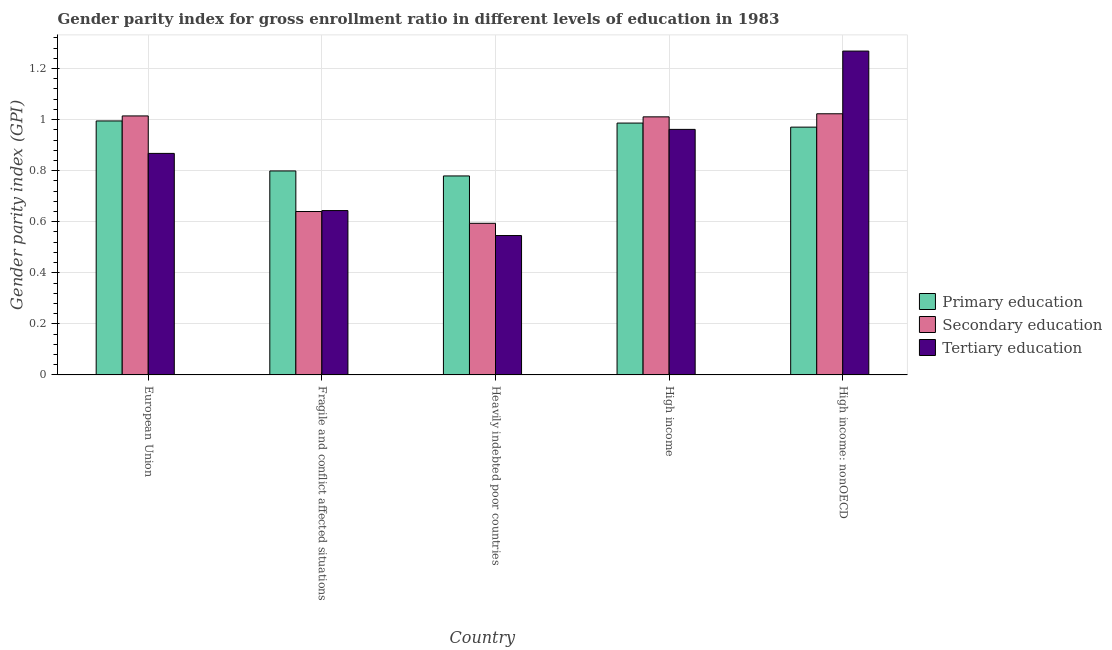Are the number of bars per tick equal to the number of legend labels?
Your answer should be compact. Yes. What is the label of the 5th group of bars from the left?
Ensure brevity in your answer.  High income: nonOECD. In how many cases, is the number of bars for a given country not equal to the number of legend labels?
Your answer should be compact. 0. What is the gender parity index in secondary education in High income?
Offer a terse response. 1.01. Across all countries, what is the maximum gender parity index in primary education?
Your answer should be very brief. 0.99. Across all countries, what is the minimum gender parity index in secondary education?
Give a very brief answer. 0.59. In which country was the gender parity index in secondary education maximum?
Make the answer very short. High income: nonOECD. In which country was the gender parity index in primary education minimum?
Offer a terse response. Heavily indebted poor countries. What is the total gender parity index in primary education in the graph?
Offer a terse response. 4.53. What is the difference between the gender parity index in secondary education in Fragile and conflict affected situations and that in Heavily indebted poor countries?
Your response must be concise. 0.05. What is the difference between the gender parity index in secondary education in Heavily indebted poor countries and the gender parity index in tertiary education in Fragile and conflict affected situations?
Make the answer very short. -0.05. What is the average gender parity index in primary education per country?
Offer a terse response. 0.91. What is the difference between the gender parity index in primary education and gender parity index in secondary education in Fragile and conflict affected situations?
Your answer should be very brief. 0.16. What is the ratio of the gender parity index in primary education in Heavily indebted poor countries to that in High income: nonOECD?
Give a very brief answer. 0.8. Is the gender parity index in primary education in Heavily indebted poor countries less than that in High income?
Offer a terse response. Yes. What is the difference between the highest and the second highest gender parity index in secondary education?
Provide a succinct answer. 0.01. What is the difference between the highest and the lowest gender parity index in secondary education?
Provide a succinct answer. 0.43. In how many countries, is the gender parity index in tertiary education greater than the average gender parity index in tertiary education taken over all countries?
Make the answer very short. 3. What does the 2nd bar from the left in Fragile and conflict affected situations represents?
Provide a short and direct response. Secondary education. What does the 3rd bar from the right in European Union represents?
Your answer should be very brief. Primary education. Is it the case that in every country, the sum of the gender parity index in primary education and gender parity index in secondary education is greater than the gender parity index in tertiary education?
Offer a very short reply. Yes. How many bars are there?
Keep it short and to the point. 15. How many countries are there in the graph?
Provide a succinct answer. 5. Are the values on the major ticks of Y-axis written in scientific E-notation?
Provide a succinct answer. No. Where does the legend appear in the graph?
Your answer should be compact. Center right. How are the legend labels stacked?
Give a very brief answer. Vertical. What is the title of the graph?
Make the answer very short. Gender parity index for gross enrollment ratio in different levels of education in 1983. What is the label or title of the Y-axis?
Your answer should be very brief. Gender parity index (GPI). What is the Gender parity index (GPI) in Primary education in European Union?
Your response must be concise. 0.99. What is the Gender parity index (GPI) of Secondary education in European Union?
Your answer should be compact. 1.01. What is the Gender parity index (GPI) of Tertiary education in European Union?
Make the answer very short. 0.87. What is the Gender parity index (GPI) in Primary education in Fragile and conflict affected situations?
Your answer should be compact. 0.8. What is the Gender parity index (GPI) of Secondary education in Fragile and conflict affected situations?
Your answer should be compact. 0.64. What is the Gender parity index (GPI) of Tertiary education in Fragile and conflict affected situations?
Give a very brief answer. 0.64. What is the Gender parity index (GPI) of Primary education in Heavily indebted poor countries?
Keep it short and to the point. 0.78. What is the Gender parity index (GPI) of Secondary education in Heavily indebted poor countries?
Offer a terse response. 0.59. What is the Gender parity index (GPI) of Tertiary education in Heavily indebted poor countries?
Keep it short and to the point. 0.55. What is the Gender parity index (GPI) of Primary education in High income?
Give a very brief answer. 0.99. What is the Gender parity index (GPI) in Secondary education in High income?
Your response must be concise. 1.01. What is the Gender parity index (GPI) of Tertiary education in High income?
Make the answer very short. 0.96. What is the Gender parity index (GPI) of Primary education in High income: nonOECD?
Give a very brief answer. 0.97. What is the Gender parity index (GPI) of Secondary education in High income: nonOECD?
Provide a short and direct response. 1.02. What is the Gender parity index (GPI) of Tertiary education in High income: nonOECD?
Provide a succinct answer. 1.27. Across all countries, what is the maximum Gender parity index (GPI) of Primary education?
Give a very brief answer. 0.99. Across all countries, what is the maximum Gender parity index (GPI) in Secondary education?
Keep it short and to the point. 1.02. Across all countries, what is the maximum Gender parity index (GPI) of Tertiary education?
Keep it short and to the point. 1.27. Across all countries, what is the minimum Gender parity index (GPI) in Primary education?
Ensure brevity in your answer.  0.78. Across all countries, what is the minimum Gender parity index (GPI) in Secondary education?
Offer a terse response. 0.59. Across all countries, what is the minimum Gender parity index (GPI) of Tertiary education?
Make the answer very short. 0.55. What is the total Gender parity index (GPI) of Primary education in the graph?
Your answer should be very brief. 4.53. What is the total Gender parity index (GPI) of Secondary education in the graph?
Ensure brevity in your answer.  4.28. What is the total Gender parity index (GPI) in Tertiary education in the graph?
Provide a succinct answer. 4.29. What is the difference between the Gender parity index (GPI) in Primary education in European Union and that in Fragile and conflict affected situations?
Offer a very short reply. 0.2. What is the difference between the Gender parity index (GPI) of Secondary education in European Union and that in Fragile and conflict affected situations?
Your answer should be very brief. 0.37. What is the difference between the Gender parity index (GPI) of Tertiary education in European Union and that in Fragile and conflict affected situations?
Provide a short and direct response. 0.22. What is the difference between the Gender parity index (GPI) in Primary education in European Union and that in Heavily indebted poor countries?
Your response must be concise. 0.22. What is the difference between the Gender parity index (GPI) of Secondary education in European Union and that in Heavily indebted poor countries?
Your response must be concise. 0.42. What is the difference between the Gender parity index (GPI) of Tertiary education in European Union and that in Heavily indebted poor countries?
Your answer should be very brief. 0.32. What is the difference between the Gender parity index (GPI) of Primary education in European Union and that in High income?
Your response must be concise. 0.01. What is the difference between the Gender parity index (GPI) in Secondary education in European Union and that in High income?
Offer a very short reply. 0. What is the difference between the Gender parity index (GPI) in Tertiary education in European Union and that in High income?
Your answer should be very brief. -0.09. What is the difference between the Gender parity index (GPI) in Primary education in European Union and that in High income: nonOECD?
Make the answer very short. 0.02. What is the difference between the Gender parity index (GPI) of Secondary education in European Union and that in High income: nonOECD?
Your answer should be very brief. -0.01. What is the difference between the Gender parity index (GPI) of Tertiary education in European Union and that in High income: nonOECD?
Your answer should be compact. -0.4. What is the difference between the Gender parity index (GPI) in Primary education in Fragile and conflict affected situations and that in Heavily indebted poor countries?
Keep it short and to the point. 0.02. What is the difference between the Gender parity index (GPI) of Secondary education in Fragile and conflict affected situations and that in Heavily indebted poor countries?
Ensure brevity in your answer.  0.05. What is the difference between the Gender parity index (GPI) of Tertiary education in Fragile and conflict affected situations and that in Heavily indebted poor countries?
Give a very brief answer. 0.1. What is the difference between the Gender parity index (GPI) of Primary education in Fragile and conflict affected situations and that in High income?
Your answer should be very brief. -0.19. What is the difference between the Gender parity index (GPI) of Secondary education in Fragile and conflict affected situations and that in High income?
Give a very brief answer. -0.37. What is the difference between the Gender parity index (GPI) in Tertiary education in Fragile and conflict affected situations and that in High income?
Provide a short and direct response. -0.32. What is the difference between the Gender parity index (GPI) in Primary education in Fragile and conflict affected situations and that in High income: nonOECD?
Provide a short and direct response. -0.17. What is the difference between the Gender parity index (GPI) of Secondary education in Fragile and conflict affected situations and that in High income: nonOECD?
Provide a succinct answer. -0.38. What is the difference between the Gender parity index (GPI) of Tertiary education in Fragile and conflict affected situations and that in High income: nonOECD?
Keep it short and to the point. -0.62. What is the difference between the Gender parity index (GPI) of Primary education in Heavily indebted poor countries and that in High income?
Offer a terse response. -0.21. What is the difference between the Gender parity index (GPI) of Secondary education in Heavily indebted poor countries and that in High income?
Your response must be concise. -0.42. What is the difference between the Gender parity index (GPI) in Tertiary education in Heavily indebted poor countries and that in High income?
Provide a succinct answer. -0.42. What is the difference between the Gender parity index (GPI) in Primary education in Heavily indebted poor countries and that in High income: nonOECD?
Your answer should be compact. -0.19. What is the difference between the Gender parity index (GPI) in Secondary education in Heavily indebted poor countries and that in High income: nonOECD?
Give a very brief answer. -0.43. What is the difference between the Gender parity index (GPI) in Tertiary education in Heavily indebted poor countries and that in High income: nonOECD?
Make the answer very short. -0.72. What is the difference between the Gender parity index (GPI) in Primary education in High income and that in High income: nonOECD?
Offer a terse response. 0.02. What is the difference between the Gender parity index (GPI) of Secondary education in High income and that in High income: nonOECD?
Provide a short and direct response. -0.01. What is the difference between the Gender parity index (GPI) of Tertiary education in High income and that in High income: nonOECD?
Ensure brevity in your answer.  -0.31. What is the difference between the Gender parity index (GPI) in Primary education in European Union and the Gender parity index (GPI) in Secondary education in Fragile and conflict affected situations?
Your answer should be compact. 0.35. What is the difference between the Gender parity index (GPI) in Primary education in European Union and the Gender parity index (GPI) in Tertiary education in Fragile and conflict affected situations?
Offer a terse response. 0.35. What is the difference between the Gender parity index (GPI) of Secondary education in European Union and the Gender parity index (GPI) of Tertiary education in Fragile and conflict affected situations?
Ensure brevity in your answer.  0.37. What is the difference between the Gender parity index (GPI) of Primary education in European Union and the Gender parity index (GPI) of Secondary education in Heavily indebted poor countries?
Keep it short and to the point. 0.4. What is the difference between the Gender parity index (GPI) in Primary education in European Union and the Gender parity index (GPI) in Tertiary education in Heavily indebted poor countries?
Your response must be concise. 0.45. What is the difference between the Gender parity index (GPI) of Secondary education in European Union and the Gender parity index (GPI) of Tertiary education in Heavily indebted poor countries?
Offer a very short reply. 0.47. What is the difference between the Gender parity index (GPI) in Primary education in European Union and the Gender parity index (GPI) in Secondary education in High income?
Offer a very short reply. -0.02. What is the difference between the Gender parity index (GPI) of Primary education in European Union and the Gender parity index (GPI) of Tertiary education in High income?
Offer a terse response. 0.03. What is the difference between the Gender parity index (GPI) of Secondary education in European Union and the Gender parity index (GPI) of Tertiary education in High income?
Provide a short and direct response. 0.05. What is the difference between the Gender parity index (GPI) in Primary education in European Union and the Gender parity index (GPI) in Secondary education in High income: nonOECD?
Provide a short and direct response. -0.03. What is the difference between the Gender parity index (GPI) of Primary education in European Union and the Gender parity index (GPI) of Tertiary education in High income: nonOECD?
Keep it short and to the point. -0.27. What is the difference between the Gender parity index (GPI) of Secondary education in European Union and the Gender parity index (GPI) of Tertiary education in High income: nonOECD?
Your answer should be compact. -0.25. What is the difference between the Gender parity index (GPI) in Primary education in Fragile and conflict affected situations and the Gender parity index (GPI) in Secondary education in Heavily indebted poor countries?
Give a very brief answer. 0.21. What is the difference between the Gender parity index (GPI) in Primary education in Fragile and conflict affected situations and the Gender parity index (GPI) in Tertiary education in Heavily indebted poor countries?
Offer a terse response. 0.25. What is the difference between the Gender parity index (GPI) of Secondary education in Fragile and conflict affected situations and the Gender parity index (GPI) of Tertiary education in Heavily indebted poor countries?
Offer a terse response. 0.09. What is the difference between the Gender parity index (GPI) in Primary education in Fragile and conflict affected situations and the Gender parity index (GPI) in Secondary education in High income?
Your answer should be compact. -0.21. What is the difference between the Gender parity index (GPI) in Primary education in Fragile and conflict affected situations and the Gender parity index (GPI) in Tertiary education in High income?
Make the answer very short. -0.16. What is the difference between the Gender parity index (GPI) of Secondary education in Fragile and conflict affected situations and the Gender parity index (GPI) of Tertiary education in High income?
Keep it short and to the point. -0.32. What is the difference between the Gender parity index (GPI) in Primary education in Fragile and conflict affected situations and the Gender parity index (GPI) in Secondary education in High income: nonOECD?
Your answer should be very brief. -0.22. What is the difference between the Gender parity index (GPI) in Primary education in Fragile and conflict affected situations and the Gender parity index (GPI) in Tertiary education in High income: nonOECD?
Make the answer very short. -0.47. What is the difference between the Gender parity index (GPI) in Secondary education in Fragile and conflict affected situations and the Gender parity index (GPI) in Tertiary education in High income: nonOECD?
Your response must be concise. -0.63. What is the difference between the Gender parity index (GPI) in Primary education in Heavily indebted poor countries and the Gender parity index (GPI) in Secondary education in High income?
Provide a succinct answer. -0.23. What is the difference between the Gender parity index (GPI) of Primary education in Heavily indebted poor countries and the Gender parity index (GPI) of Tertiary education in High income?
Your answer should be very brief. -0.18. What is the difference between the Gender parity index (GPI) in Secondary education in Heavily indebted poor countries and the Gender parity index (GPI) in Tertiary education in High income?
Keep it short and to the point. -0.37. What is the difference between the Gender parity index (GPI) in Primary education in Heavily indebted poor countries and the Gender parity index (GPI) in Secondary education in High income: nonOECD?
Offer a terse response. -0.24. What is the difference between the Gender parity index (GPI) in Primary education in Heavily indebted poor countries and the Gender parity index (GPI) in Tertiary education in High income: nonOECD?
Provide a succinct answer. -0.49. What is the difference between the Gender parity index (GPI) of Secondary education in Heavily indebted poor countries and the Gender parity index (GPI) of Tertiary education in High income: nonOECD?
Give a very brief answer. -0.67. What is the difference between the Gender parity index (GPI) of Primary education in High income and the Gender parity index (GPI) of Secondary education in High income: nonOECD?
Your answer should be very brief. -0.04. What is the difference between the Gender parity index (GPI) in Primary education in High income and the Gender parity index (GPI) in Tertiary education in High income: nonOECD?
Offer a terse response. -0.28. What is the difference between the Gender parity index (GPI) in Secondary education in High income and the Gender parity index (GPI) in Tertiary education in High income: nonOECD?
Give a very brief answer. -0.26. What is the average Gender parity index (GPI) of Primary education per country?
Your answer should be very brief. 0.91. What is the average Gender parity index (GPI) in Secondary education per country?
Provide a succinct answer. 0.86. What is the average Gender parity index (GPI) in Tertiary education per country?
Your response must be concise. 0.86. What is the difference between the Gender parity index (GPI) in Primary education and Gender parity index (GPI) in Secondary education in European Union?
Your response must be concise. -0.02. What is the difference between the Gender parity index (GPI) of Primary education and Gender parity index (GPI) of Tertiary education in European Union?
Your answer should be compact. 0.13. What is the difference between the Gender parity index (GPI) of Secondary education and Gender parity index (GPI) of Tertiary education in European Union?
Ensure brevity in your answer.  0.15. What is the difference between the Gender parity index (GPI) of Primary education and Gender parity index (GPI) of Secondary education in Fragile and conflict affected situations?
Your answer should be compact. 0.16. What is the difference between the Gender parity index (GPI) of Primary education and Gender parity index (GPI) of Tertiary education in Fragile and conflict affected situations?
Provide a short and direct response. 0.16. What is the difference between the Gender parity index (GPI) of Secondary education and Gender parity index (GPI) of Tertiary education in Fragile and conflict affected situations?
Offer a terse response. -0. What is the difference between the Gender parity index (GPI) in Primary education and Gender parity index (GPI) in Secondary education in Heavily indebted poor countries?
Give a very brief answer. 0.19. What is the difference between the Gender parity index (GPI) in Primary education and Gender parity index (GPI) in Tertiary education in Heavily indebted poor countries?
Your answer should be compact. 0.23. What is the difference between the Gender parity index (GPI) in Secondary education and Gender parity index (GPI) in Tertiary education in Heavily indebted poor countries?
Your response must be concise. 0.05. What is the difference between the Gender parity index (GPI) of Primary education and Gender parity index (GPI) of Secondary education in High income?
Provide a succinct answer. -0.02. What is the difference between the Gender parity index (GPI) in Primary education and Gender parity index (GPI) in Tertiary education in High income?
Your answer should be compact. 0.02. What is the difference between the Gender parity index (GPI) in Secondary education and Gender parity index (GPI) in Tertiary education in High income?
Offer a terse response. 0.05. What is the difference between the Gender parity index (GPI) of Primary education and Gender parity index (GPI) of Secondary education in High income: nonOECD?
Give a very brief answer. -0.05. What is the difference between the Gender parity index (GPI) of Primary education and Gender parity index (GPI) of Tertiary education in High income: nonOECD?
Your response must be concise. -0.3. What is the difference between the Gender parity index (GPI) in Secondary education and Gender parity index (GPI) in Tertiary education in High income: nonOECD?
Offer a very short reply. -0.25. What is the ratio of the Gender parity index (GPI) in Primary education in European Union to that in Fragile and conflict affected situations?
Ensure brevity in your answer.  1.25. What is the ratio of the Gender parity index (GPI) in Secondary education in European Union to that in Fragile and conflict affected situations?
Your answer should be very brief. 1.59. What is the ratio of the Gender parity index (GPI) of Tertiary education in European Union to that in Fragile and conflict affected situations?
Your answer should be very brief. 1.35. What is the ratio of the Gender parity index (GPI) of Primary education in European Union to that in Heavily indebted poor countries?
Make the answer very short. 1.28. What is the ratio of the Gender parity index (GPI) in Secondary education in European Union to that in Heavily indebted poor countries?
Your response must be concise. 1.71. What is the ratio of the Gender parity index (GPI) of Tertiary education in European Union to that in Heavily indebted poor countries?
Ensure brevity in your answer.  1.59. What is the ratio of the Gender parity index (GPI) in Primary education in European Union to that in High income?
Ensure brevity in your answer.  1.01. What is the ratio of the Gender parity index (GPI) of Secondary education in European Union to that in High income?
Offer a terse response. 1. What is the ratio of the Gender parity index (GPI) of Tertiary education in European Union to that in High income?
Offer a very short reply. 0.9. What is the ratio of the Gender parity index (GPI) of Tertiary education in European Union to that in High income: nonOECD?
Your response must be concise. 0.68. What is the ratio of the Gender parity index (GPI) in Primary education in Fragile and conflict affected situations to that in Heavily indebted poor countries?
Your response must be concise. 1.03. What is the ratio of the Gender parity index (GPI) of Secondary education in Fragile and conflict affected situations to that in Heavily indebted poor countries?
Ensure brevity in your answer.  1.08. What is the ratio of the Gender parity index (GPI) of Tertiary education in Fragile and conflict affected situations to that in Heavily indebted poor countries?
Keep it short and to the point. 1.18. What is the ratio of the Gender parity index (GPI) in Primary education in Fragile and conflict affected situations to that in High income?
Your answer should be very brief. 0.81. What is the ratio of the Gender parity index (GPI) of Secondary education in Fragile and conflict affected situations to that in High income?
Offer a terse response. 0.63. What is the ratio of the Gender parity index (GPI) in Tertiary education in Fragile and conflict affected situations to that in High income?
Ensure brevity in your answer.  0.67. What is the ratio of the Gender parity index (GPI) in Primary education in Fragile and conflict affected situations to that in High income: nonOECD?
Offer a very short reply. 0.82. What is the ratio of the Gender parity index (GPI) of Secondary education in Fragile and conflict affected situations to that in High income: nonOECD?
Your answer should be compact. 0.63. What is the ratio of the Gender parity index (GPI) of Tertiary education in Fragile and conflict affected situations to that in High income: nonOECD?
Offer a very short reply. 0.51. What is the ratio of the Gender parity index (GPI) of Primary education in Heavily indebted poor countries to that in High income?
Offer a terse response. 0.79. What is the ratio of the Gender parity index (GPI) in Secondary education in Heavily indebted poor countries to that in High income?
Keep it short and to the point. 0.59. What is the ratio of the Gender parity index (GPI) of Tertiary education in Heavily indebted poor countries to that in High income?
Your answer should be very brief. 0.57. What is the ratio of the Gender parity index (GPI) of Primary education in Heavily indebted poor countries to that in High income: nonOECD?
Provide a short and direct response. 0.8. What is the ratio of the Gender parity index (GPI) of Secondary education in Heavily indebted poor countries to that in High income: nonOECD?
Keep it short and to the point. 0.58. What is the ratio of the Gender parity index (GPI) in Tertiary education in Heavily indebted poor countries to that in High income: nonOECD?
Your response must be concise. 0.43. What is the ratio of the Gender parity index (GPI) in Primary education in High income to that in High income: nonOECD?
Ensure brevity in your answer.  1.02. What is the ratio of the Gender parity index (GPI) in Secondary education in High income to that in High income: nonOECD?
Your answer should be very brief. 0.99. What is the ratio of the Gender parity index (GPI) in Tertiary education in High income to that in High income: nonOECD?
Provide a short and direct response. 0.76. What is the difference between the highest and the second highest Gender parity index (GPI) of Primary education?
Ensure brevity in your answer.  0.01. What is the difference between the highest and the second highest Gender parity index (GPI) in Secondary education?
Provide a short and direct response. 0.01. What is the difference between the highest and the second highest Gender parity index (GPI) of Tertiary education?
Ensure brevity in your answer.  0.31. What is the difference between the highest and the lowest Gender parity index (GPI) in Primary education?
Your answer should be compact. 0.22. What is the difference between the highest and the lowest Gender parity index (GPI) of Secondary education?
Give a very brief answer. 0.43. What is the difference between the highest and the lowest Gender parity index (GPI) of Tertiary education?
Provide a short and direct response. 0.72. 